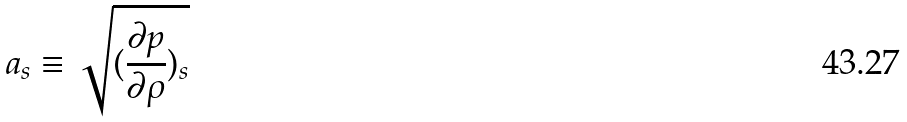<formula> <loc_0><loc_0><loc_500><loc_500>a _ { s } \equiv \sqrt { ( \frac { \partial p } { \partial \rho } ) _ { s } }</formula> 